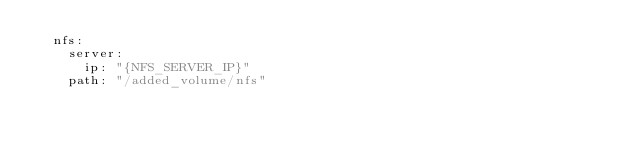<code> <loc_0><loc_0><loc_500><loc_500><_YAML_>  nfs:
    server:
      ip: "{NFS_SERVER_IP}"
    path: "/added_volume/nfs"
</code> 